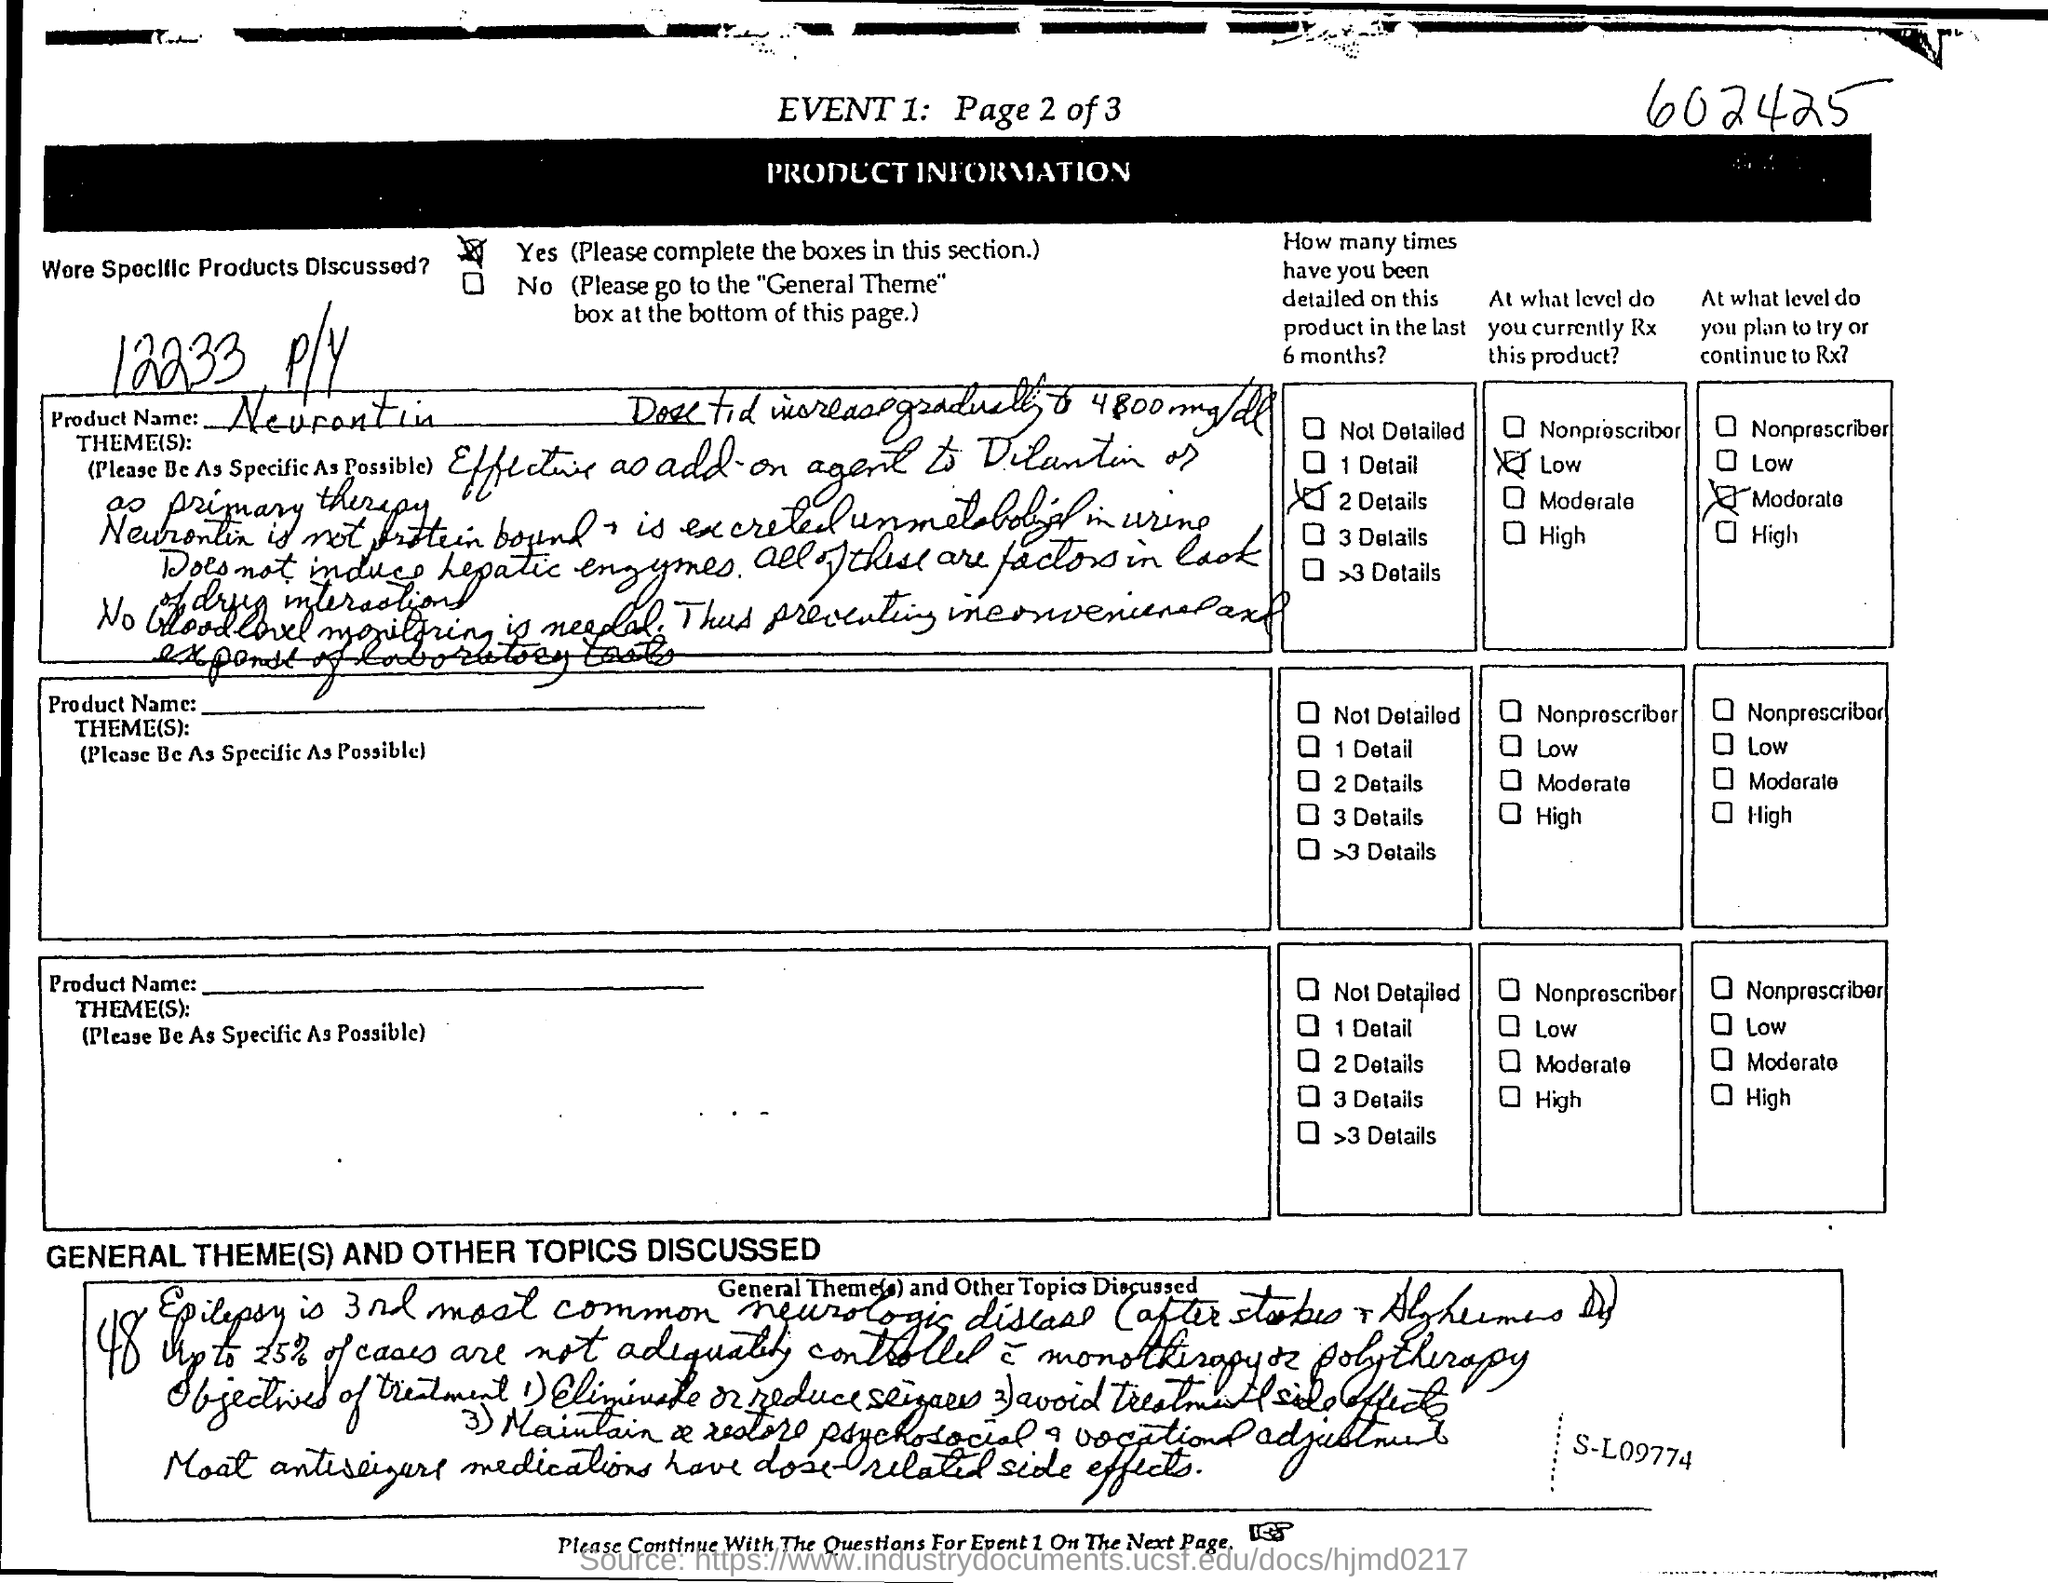Indicate a few pertinent items in this graphic. The product name is Neurontin. 